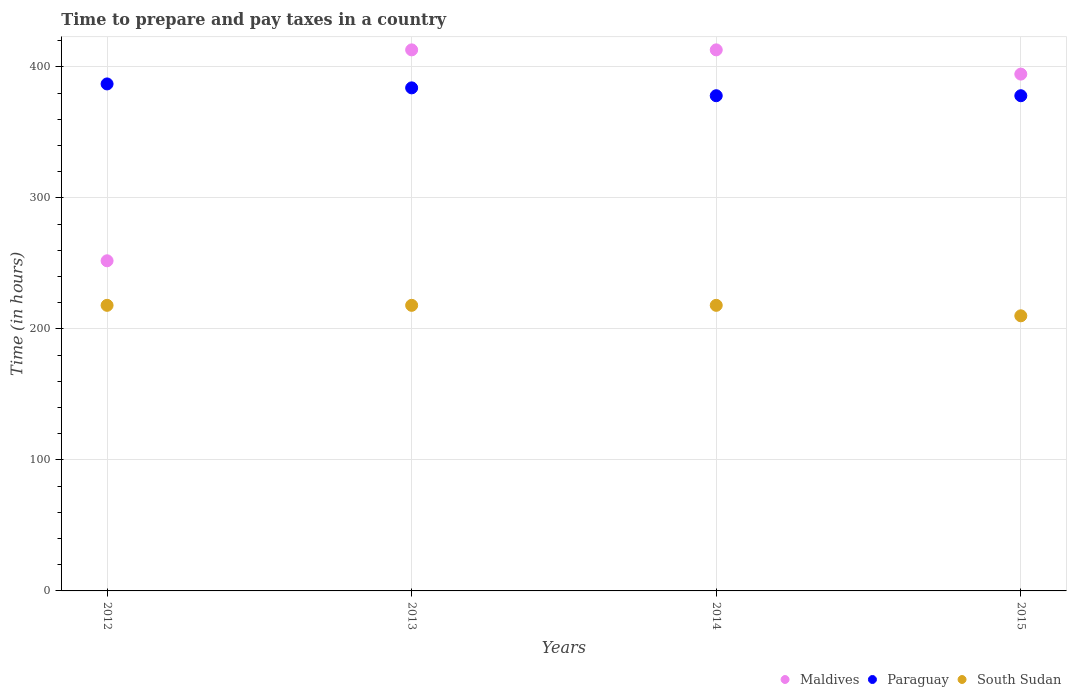How many different coloured dotlines are there?
Your answer should be very brief. 3. Is the number of dotlines equal to the number of legend labels?
Your answer should be compact. Yes. What is the number of hours required to prepare and pay taxes in South Sudan in 2014?
Your answer should be compact. 218. Across all years, what is the maximum number of hours required to prepare and pay taxes in Paraguay?
Your answer should be very brief. 387. Across all years, what is the minimum number of hours required to prepare and pay taxes in Paraguay?
Offer a very short reply. 378. In which year was the number of hours required to prepare and pay taxes in South Sudan minimum?
Offer a terse response. 2015. What is the total number of hours required to prepare and pay taxes in Maldives in the graph?
Your answer should be very brief. 1472.5. What is the difference between the number of hours required to prepare and pay taxes in Paraguay in 2013 and that in 2015?
Offer a very short reply. 6. What is the difference between the number of hours required to prepare and pay taxes in Paraguay in 2013 and the number of hours required to prepare and pay taxes in Maldives in 2012?
Offer a very short reply. 132. What is the average number of hours required to prepare and pay taxes in South Sudan per year?
Ensure brevity in your answer.  216. In the year 2015, what is the difference between the number of hours required to prepare and pay taxes in Maldives and number of hours required to prepare and pay taxes in South Sudan?
Offer a very short reply. 184.5. What is the ratio of the number of hours required to prepare and pay taxes in Maldives in 2013 to that in 2014?
Give a very brief answer. 1. What is the difference between the highest and the lowest number of hours required to prepare and pay taxes in Maldives?
Provide a short and direct response. 161. Is the number of hours required to prepare and pay taxes in South Sudan strictly less than the number of hours required to prepare and pay taxes in Maldives over the years?
Give a very brief answer. Yes. How many years are there in the graph?
Keep it short and to the point. 4. What is the difference between two consecutive major ticks on the Y-axis?
Keep it short and to the point. 100. Does the graph contain any zero values?
Make the answer very short. No. Does the graph contain grids?
Give a very brief answer. Yes. Where does the legend appear in the graph?
Provide a short and direct response. Bottom right. How are the legend labels stacked?
Offer a terse response. Horizontal. What is the title of the graph?
Your response must be concise. Time to prepare and pay taxes in a country. What is the label or title of the X-axis?
Give a very brief answer. Years. What is the label or title of the Y-axis?
Ensure brevity in your answer.  Time (in hours). What is the Time (in hours) of Maldives in 2012?
Offer a terse response. 252. What is the Time (in hours) in Paraguay in 2012?
Your response must be concise. 387. What is the Time (in hours) of South Sudan in 2012?
Offer a very short reply. 218. What is the Time (in hours) of Maldives in 2013?
Your answer should be very brief. 413. What is the Time (in hours) of Paraguay in 2013?
Provide a succinct answer. 384. What is the Time (in hours) of South Sudan in 2013?
Your response must be concise. 218. What is the Time (in hours) in Maldives in 2014?
Give a very brief answer. 413. What is the Time (in hours) of Paraguay in 2014?
Provide a succinct answer. 378. What is the Time (in hours) in South Sudan in 2014?
Ensure brevity in your answer.  218. What is the Time (in hours) of Maldives in 2015?
Keep it short and to the point. 394.5. What is the Time (in hours) in Paraguay in 2015?
Give a very brief answer. 378. What is the Time (in hours) of South Sudan in 2015?
Offer a very short reply. 210. Across all years, what is the maximum Time (in hours) in Maldives?
Your response must be concise. 413. Across all years, what is the maximum Time (in hours) of Paraguay?
Make the answer very short. 387. Across all years, what is the maximum Time (in hours) of South Sudan?
Your answer should be compact. 218. Across all years, what is the minimum Time (in hours) of Maldives?
Provide a succinct answer. 252. Across all years, what is the minimum Time (in hours) in Paraguay?
Keep it short and to the point. 378. Across all years, what is the minimum Time (in hours) of South Sudan?
Keep it short and to the point. 210. What is the total Time (in hours) in Maldives in the graph?
Ensure brevity in your answer.  1472.5. What is the total Time (in hours) in Paraguay in the graph?
Ensure brevity in your answer.  1527. What is the total Time (in hours) of South Sudan in the graph?
Your answer should be compact. 864. What is the difference between the Time (in hours) in Maldives in 2012 and that in 2013?
Provide a short and direct response. -161. What is the difference between the Time (in hours) in Maldives in 2012 and that in 2014?
Provide a succinct answer. -161. What is the difference between the Time (in hours) of Paraguay in 2012 and that in 2014?
Give a very brief answer. 9. What is the difference between the Time (in hours) of South Sudan in 2012 and that in 2014?
Your answer should be compact. 0. What is the difference between the Time (in hours) in Maldives in 2012 and that in 2015?
Keep it short and to the point. -142.5. What is the difference between the Time (in hours) of Maldives in 2013 and that in 2014?
Provide a short and direct response. 0. What is the difference between the Time (in hours) of Maldives in 2013 and that in 2015?
Offer a terse response. 18.5. What is the difference between the Time (in hours) of South Sudan in 2013 and that in 2015?
Your response must be concise. 8. What is the difference between the Time (in hours) in Paraguay in 2014 and that in 2015?
Offer a very short reply. 0. What is the difference between the Time (in hours) in South Sudan in 2014 and that in 2015?
Your response must be concise. 8. What is the difference between the Time (in hours) of Maldives in 2012 and the Time (in hours) of Paraguay in 2013?
Your response must be concise. -132. What is the difference between the Time (in hours) of Paraguay in 2012 and the Time (in hours) of South Sudan in 2013?
Your response must be concise. 169. What is the difference between the Time (in hours) of Maldives in 2012 and the Time (in hours) of Paraguay in 2014?
Make the answer very short. -126. What is the difference between the Time (in hours) of Paraguay in 2012 and the Time (in hours) of South Sudan in 2014?
Give a very brief answer. 169. What is the difference between the Time (in hours) in Maldives in 2012 and the Time (in hours) in Paraguay in 2015?
Offer a terse response. -126. What is the difference between the Time (in hours) in Maldives in 2012 and the Time (in hours) in South Sudan in 2015?
Ensure brevity in your answer.  42. What is the difference between the Time (in hours) in Paraguay in 2012 and the Time (in hours) in South Sudan in 2015?
Ensure brevity in your answer.  177. What is the difference between the Time (in hours) of Maldives in 2013 and the Time (in hours) of Paraguay in 2014?
Provide a succinct answer. 35. What is the difference between the Time (in hours) of Maldives in 2013 and the Time (in hours) of South Sudan in 2014?
Provide a succinct answer. 195. What is the difference between the Time (in hours) in Paraguay in 2013 and the Time (in hours) in South Sudan in 2014?
Your answer should be compact. 166. What is the difference between the Time (in hours) of Maldives in 2013 and the Time (in hours) of South Sudan in 2015?
Your answer should be compact. 203. What is the difference between the Time (in hours) in Paraguay in 2013 and the Time (in hours) in South Sudan in 2015?
Ensure brevity in your answer.  174. What is the difference between the Time (in hours) of Maldives in 2014 and the Time (in hours) of South Sudan in 2015?
Make the answer very short. 203. What is the difference between the Time (in hours) in Paraguay in 2014 and the Time (in hours) in South Sudan in 2015?
Your answer should be very brief. 168. What is the average Time (in hours) in Maldives per year?
Your answer should be compact. 368.12. What is the average Time (in hours) of Paraguay per year?
Offer a terse response. 381.75. What is the average Time (in hours) in South Sudan per year?
Offer a very short reply. 216. In the year 2012, what is the difference between the Time (in hours) of Maldives and Time (in hours) of Paraguay?
Your answer should be compact. -135. In the year 2012, what is the difference between the Time (in hours) in Paraguay and Time (in hours) in South Sudan?
Give a very brief answer. 169. In the year 2013, what is the difference between the Time (in hours) in Maldives and Time (in hours) in South Sudan?
Your answer should be compact. 195. In the year 2013, what is the difference between the Time (in hours) of Paraguay and Time (in hours) of South Sudan?
Your response must be concise. 166. In the year 2014, what is the difference between the Time (in hours) of Maldives and Time (in hours) of Paraguay?
Your answer should be compact. 35. In the year 2014, what is the difference between the Time (in hours) in Maldives and Time (in hours) in South Sudan?
Make the answer very short. 195. In the year 2014, what is the difference between the Time (in hours) of Paraguay and Time (in hours) of South Sudan?
Provide a succinct answer. 160. In the year 2015, what is the difference between the Time (in hours) of Maldives and Time (in hours) of South Sudan?
Provide a succinct answer. 184.5. In the year 2015, what is the difference between the Time (in hours) in Paraguay and Time (in hours) in South Sudan?
Offer a terse response. 168. What is the ratio of the Time (in hours) in Maldives in 2012 to that in 2013?
Provide a short and direct response. 0.61. What is the ratio of the Time (in hours) of Maldives in 2012 to that in 2014?
Give a very brief answer. 0.61. What is the ratio of the Time (in hours) of Paraguay in 2012 to that in 2014?
Keep it short and to the point. 1.02. What is the ratio of the Time (in hours) of Maldives in 2012 to that in 2015?
Offer a very short reply. 0.64. What is the ratio of the Time (in hours) of Paraguay in 2012 to that in 2015?
Make the answer very short. 1.02. What is the ratio of the Time (in hours) of South Sudan in 2012 to that in 2015?
Provide a succinct answer. 1.04. What is the ratio of the Time (in hours) of Paraguay in 2013 to that in 2014?
Offer a very short reply. 1.02. What is the ratio of the Time (in hours) in South Sudan in 2013 to that in 2014?
Keep it short and to the point. 1. What is the ratio of the Time (in hours) in Maldives in 2013 to that in 2015?
Offer a very short reply. 1.05. What is the ratio of the Time (in hours) of Paraguay in 2013 to that in 2015?
Make the answer very short. 1.02. What is the ratio of the Time (in hours) of South Sudan in 2013 to that in 2015?
Provide a succinct answer. 1.04. What is the ratio of the Time (in hours) in Maldives in 2014 to that in 2015?
Give a very brief answer. 1.05. What is the ratio of the Time (in hours) of Paraguay in 2014 to that in 2015?
Ensure brevity in your answer.  1. What is the ratio of the Time (in hours) of South Sudan in 2014 to that in 2015?
Make the answer very short. 1.04. What is the difference between the highest and the second highest Time (in hours) of Maldives?
Keep it short and to the point. 0. What is the difference between the highest and the second highest Time (in hours) of Paraguay?
Your answer should be compact. 3. What is the difference between the highest and the second highest Time (in hours) in South Sudan?
Offer a very short reply. 0. What is the difference between the highest and the lowest Time (in hours) in Maldives?
Your response must be concise. 161. What is the difference between the highest and the lowest Time (in hours) in Paraguay?
Provide a short and direct response. 9. 